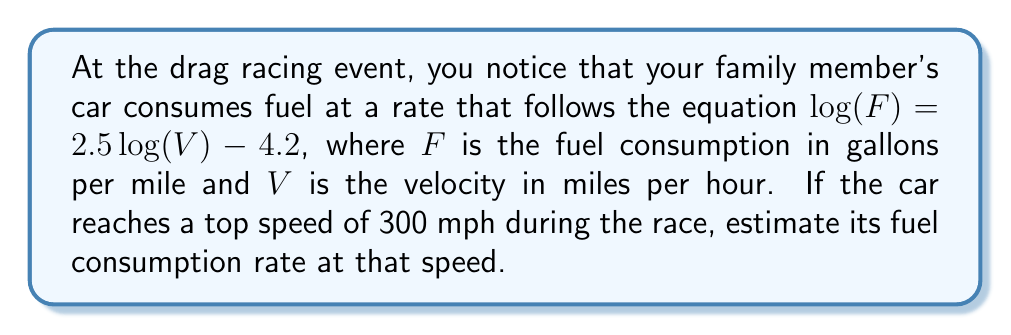Can you solve this math problem? Let's approach this step-by-step:

1) We're given the equation $\log(F) = 2.5\log(V) - 4.2$, where $F$ is fuel consumption and $V$ is velocity.

2) We need to find $F$ when $V = 300$ mph.

3) Let's substitute $V = 300$ into the equation:

   $\log(F) = 2.5\log(300) - 4.2$

4) Now, let's calculate $\log(300)$:
   
   $\log(300) \approx 2.4771$

5) Substituting this back:

   $\log(F) = 2.5(2.4771) - 4.2$
   
   $\log(F) = 6.1928 - 4.2$
   
   $\log(F) = 1.9928$

6) To find $F$, we need to apply the inverse function (antilog or $10^x$):

   $F = 10^{1.9928}$

7) Calculating this:

   $F \approx 98.4$ gallons per mile

Therefore, at 300 mph, the car is estimated to consume about 98.4 gallons of fuel per mile.
Answer: $98.4$ gallons per mile 